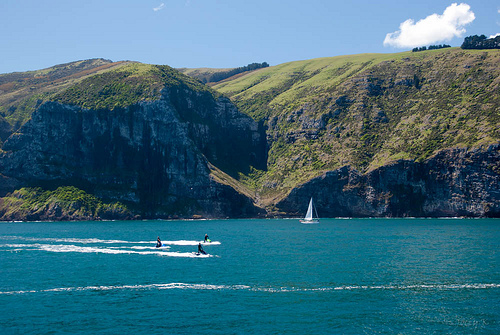<image>
Can you confirm if the boat is in the water? Yes. The boat is contained within or inside the water, showing a containment relationship. 